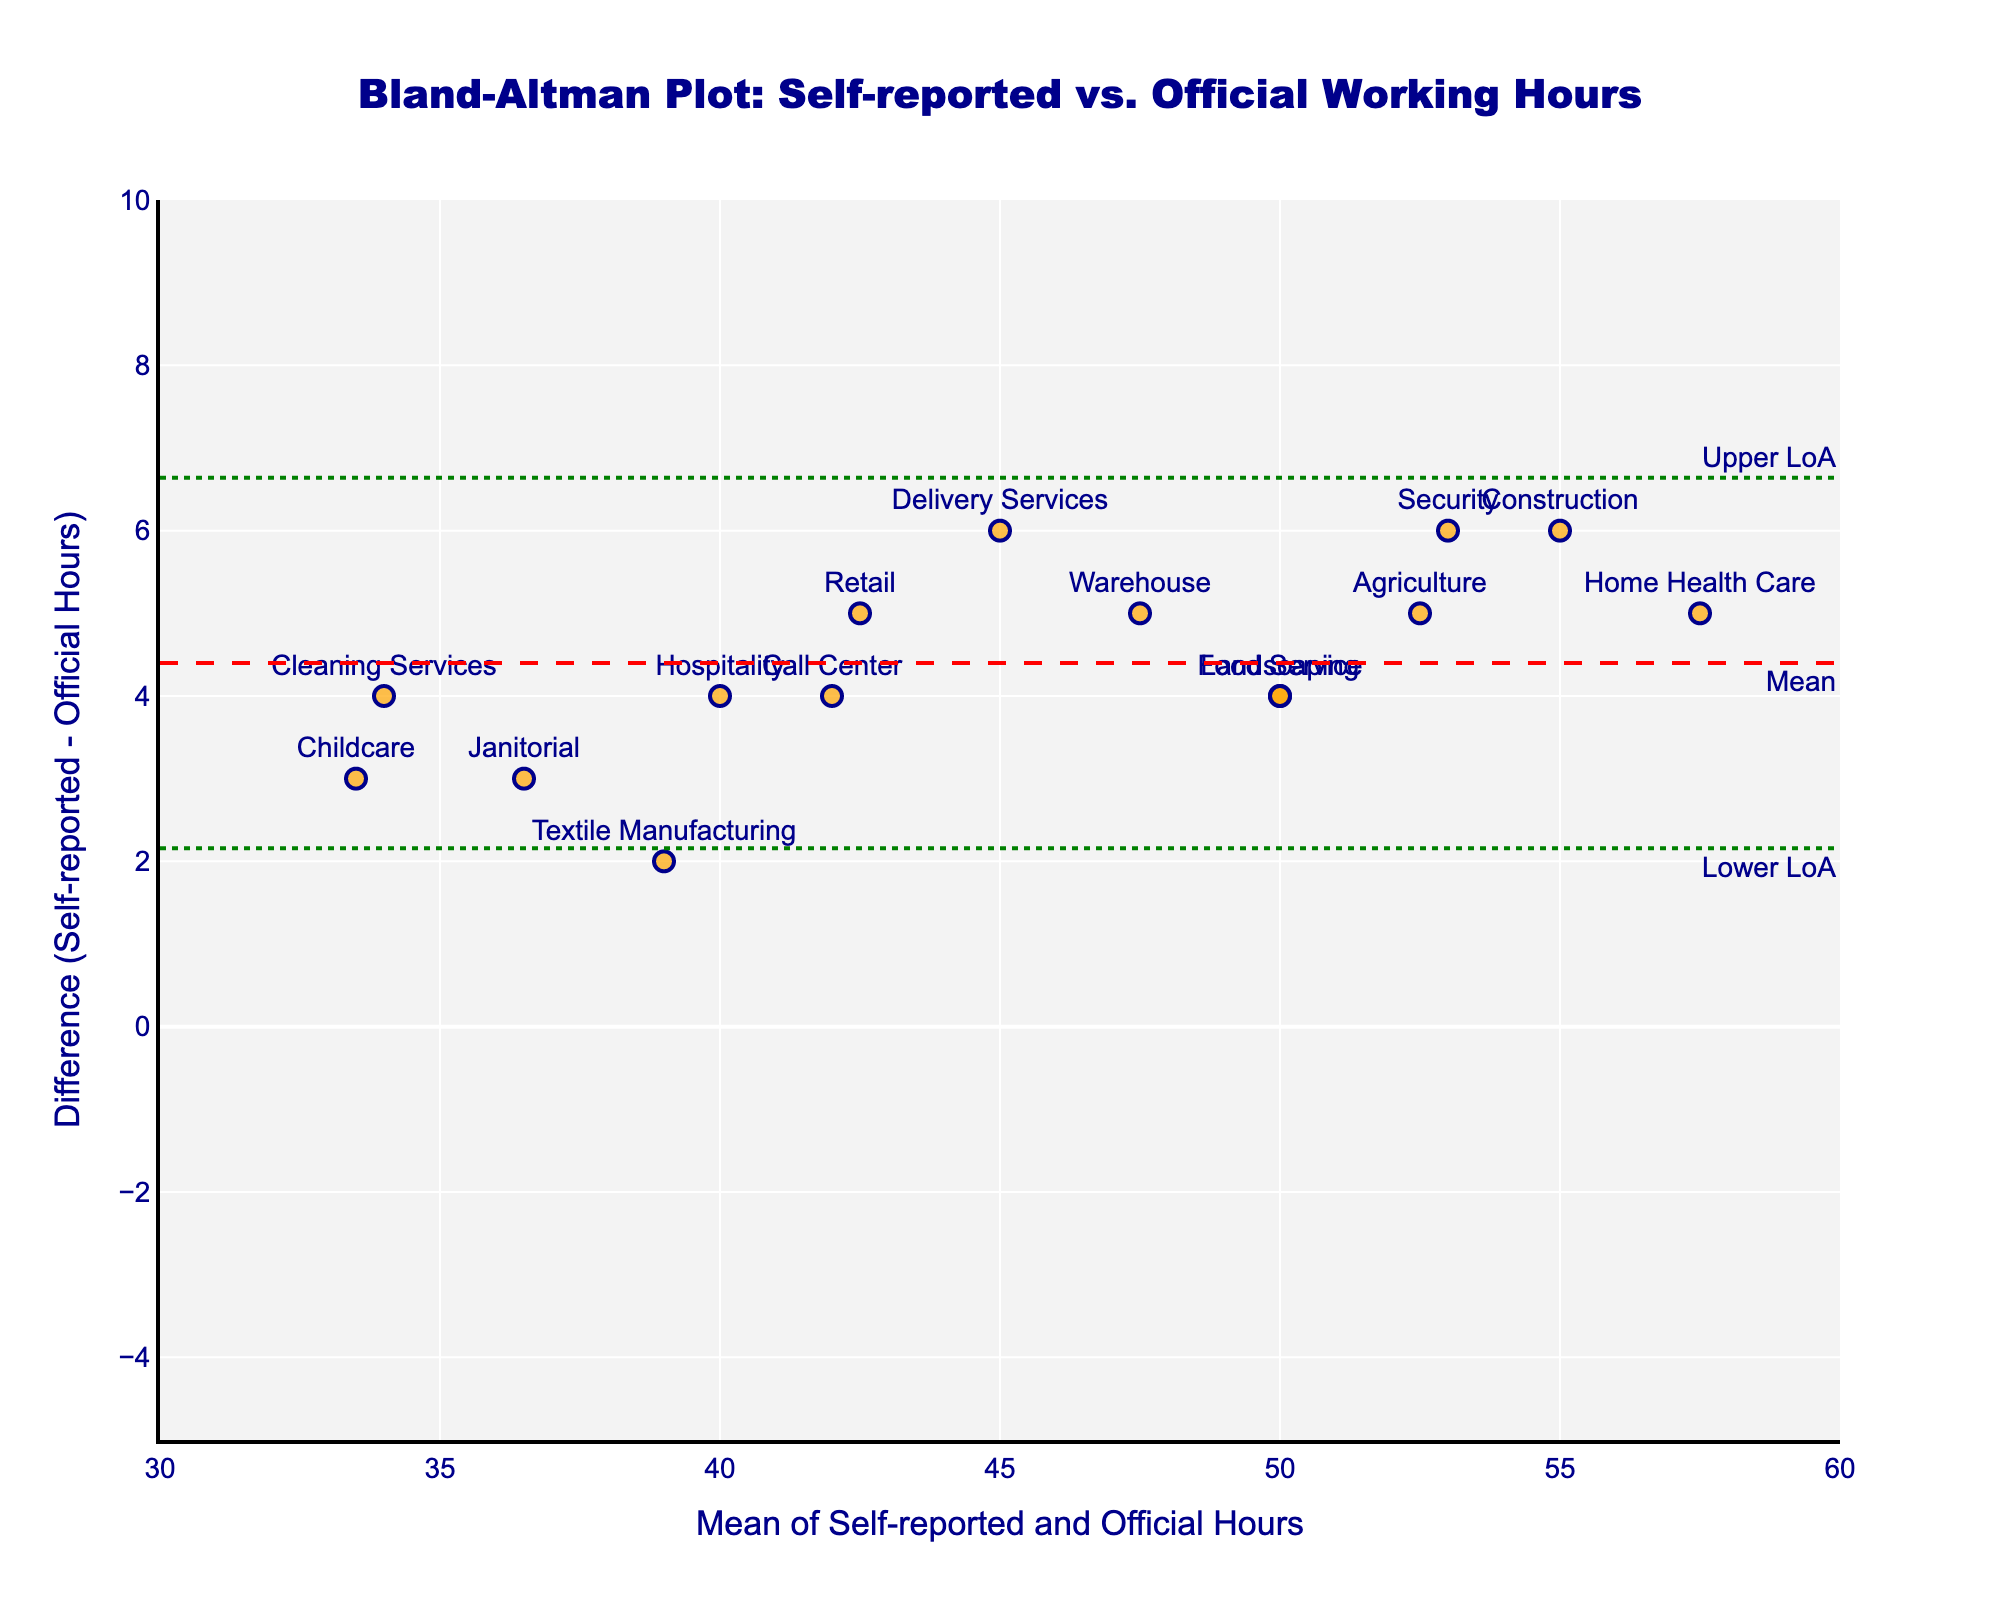What's the title of the figure? The title is displayed at the top of the plot. It provides a summary of what the figure represents. In this case, the title is "Bland-Altman Plot: Self-reported vs. Official Working Hours".
Answer: Bland-Altman Plot: Self-reported vs. Official Working Hours How many industries are represented in this plot? Each data point in the scatter plot represents an industry. By counting the unique data points labeled with each industry, we find that there are 15 industries.
Answer: 15 What is the difference value for the Retail industry? Locate the point labeled "Retail" on the plot and check its y-coordinate, which represents the difference between self-reported and official working hours for the Retail industry. It is 5.
Answer: 5 Which industry has the largest difference between self-reported and official working hours? Find the point with the highest y-coordinate on the plot, as this represents the largest positive difference. The "Home Health Care" industry shows the largest difference of 5 hours.
Answer: Home Health Care What are the lower and upper limits of agreement (LoA)? The lower and upper limits of agreement are represented by the horizontal dotted lines on the plot, annotated as "Lower LoA" and "Upper LoA". The lower limit is approximately -0.47 and the upper limit is approximately 7.47.
Answer: -0.47 and 7.47 Describe the shape of the marker representing data points. The shape of the marker used in the scatter plot is a circle.
Answer: Circle Which data point has the smallest mean hours and what industry does it represent? Identify the data point with the smallest x-coordinate, as the x-axis represents the mean of self-reported and official hours. It is the Childcare industry with a mean of 33.5 hours.
Answer: Childcare and 33.5 hours For which industry is the difference negative and what is its value? Look for points below the x-axis since a negative difference means the self-reported hours are less than the official hours. The industry with a negative difference is Cleaning Services with a difference of -4.
Answer: Cleaning Services and -4 What is the color of the lines representing the mean and limits of agreement? Identify the color used for the horizontal lines annotated as mean, lower limit, and upper limit. The mean difference line is red, while the limits of agreement (LoA) lines are green.
Answer: Red and Green 